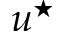<formula> <loc_0><loc_0><loc_500><loc_500>u ^ { ^ { * } }</formula> 